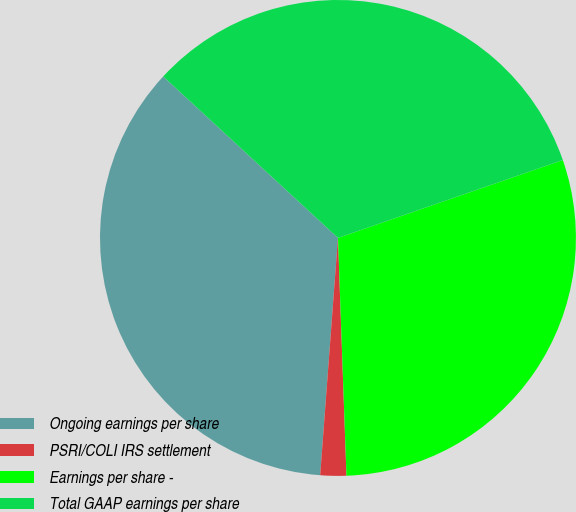Convert chart to OTSL. <chart><loc_0><loc_0><loc_500><loc_500><pie_chart><fcel>Ongoing earnings per share<fcel>PSRI/COLI IRS settlement<fcel>Earnings per share -<fcel>Total GAAP earnings per share<nl><fcel>35.68%<fcel>1.76%<fcel>29.74%<fcel>32.82%<nl></chart> 